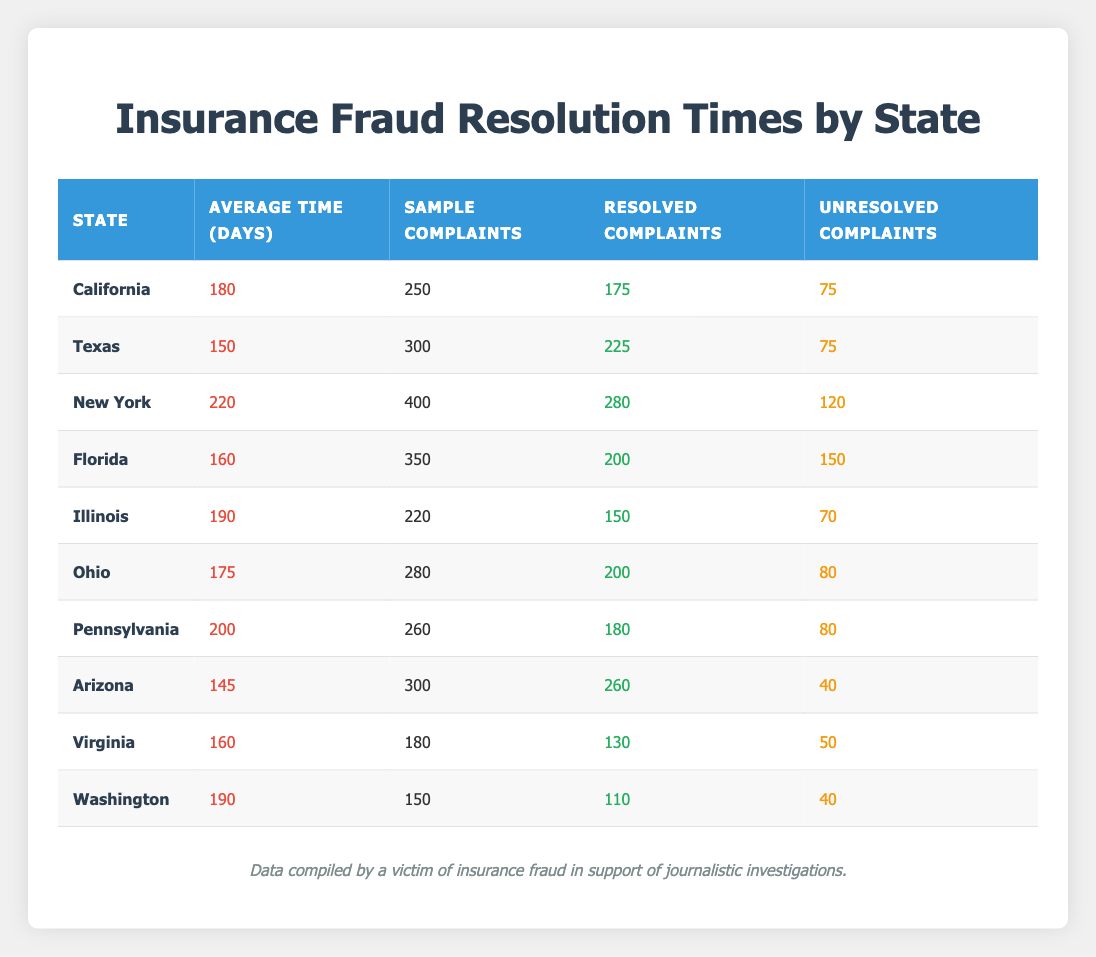What is the average resolution time for insurance fraud complaints in California? In the table, for California, the average time to resolve complaints is listed under the "Average Time (Days)" column, which shows 180 days.
Answer: 180 days Which state has the shortest average resolution time? Reviewing the "Average Time (Days)" column, Arizona has the shortest average resolution time at 145 days, which is less than any other state listed.
Answer: Arizona How many unresolved complaints are there in New York? In the table, the "Unresolved Complaints" column for New York shows a value of 120 complaints.
Answer: 120 complaints Is it true that Florida has more unresolved complaints than Virginia? Looking at the "Unresolved Complaints" column, Florida has 150 unresolved complaints while Virginia has 50. This confirms that Florida does have more unresolved complaints than Virginia.
Answer: Yes What is the average of resolved complaints across all states? To compute the average, we sum the resolved complaints across all states: 175 + 225 + 280 + 200 + 150 + 200 + 180 + 260 + 130 + 110 = 2020. There are 10 states, so the average is 2020/10 = 202.
Answer: 202 How many states have an average resolution time longer than 180 days? By checking the "Average Time (Days)" column, we find that New York (220), Illinois (190), and Pennsylvania (200) have averages over 180 days. Therefore, there are three states with longer resolution times.
Answer: 3 What is the difference in the number of sample complaints between Texas and Ohio? For Texas, the number of sample complaints is 300, and for Ohio, it is 280. The difference is calculated by subtracting: 300 - 280 = 20.
Answer: 20 Which state has the highest number of resolved complaints? Inspecting the "Resolved Complaints" column, we find that Texas has the highest number with 225 complaints resolved.
Answer: Texas Calculate the total number of complaints (resolved + unresolved) in Pennsylvania. In Pennsylvania, the resolved complaints are 180 and the unresolved complaints are 80. The total number of complaints is 180 + 80 = 260.
Answer: 260 